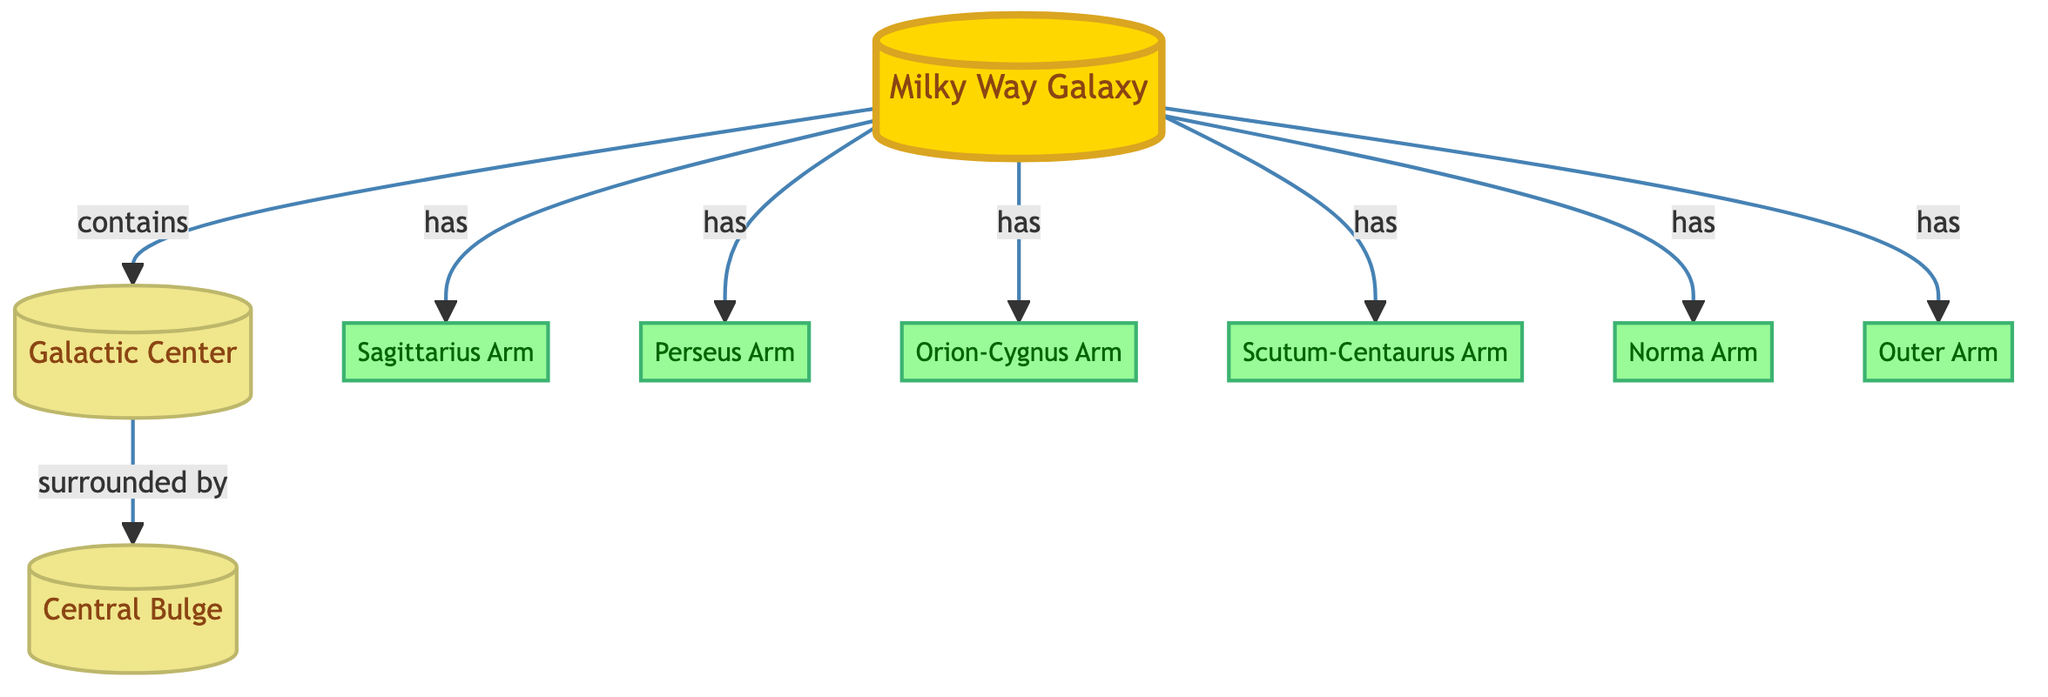What is the central feature of the Milky Way Galaxy? The central feature is the "Galactic Center," which is directly connected to the Milky Way Galaxy in the diagram.
Answer: Galactic Center How many spiral arms are shown in the diagram? The diagram indicates the presence of six spiral arms branching from the Milky Way Galaxy, each labeled as an arm, which are connected by the 'has' relationship.
Answer: 6 Which arm is directly linked to the Central Bulge? The "Central Bulge" is surrounded by the "Galactic Center," which connects to it in the diagram; however, the arms do not directly link to it. Since there is no arm connected directly to the Central Bulge, there is no answer for this question based on the tree structure shown.
Answer: None List the names of the spiral arms. The spiral arms listed in the diagram include Sagittarius Arm, Perseus Arm, Orion-Cygnus Arm, Scutum-Centaurus Arm, Norma Arm, and Outer Arm; each is directly associated with the Milky Way Galaxy node.
Answer: Sagittarius Arm, Perseus Arm, Orion-Cygnus Arm, Scutum-Centaurus Arm, Norma Arm, Outer Arm Which spiral arm is located closest to the Galactic Center? The "Orion-Cygnus Arm" is commonly recognized as the one nearest to the Galactic Center based on its position in the visual layout; it is a central feature among the arms listed in relation to the central nodes.
Answer: Orion-Cygnus Arm Is the Norma arm linked to the Milky Way galaxy? The diagram explicitly indicates that the "Norma Arm" is connected to the "Milky Way Galaxy" with the 'has' relationship, showing that it is a component within this structure.
Answer: Yes What does the Milky Way Galaxy contain according to the diagram? The Milky Way Galaxy contains various features, including Central Bulge, Galactic Center, and six identifiable spiral arms, as represented in their respective relationships.
Answer: Central Bulge, Galactic Center, 6 arms Which spiral arm has a name starting with 'S'? The diagram shows two arms beginning with 'S': "Sagittarius Arm" and "Scutum-Centaurus Arm," indicating they are both part of the structure.
Answer: Sagittarius Arm, Scutum-Centaurus Arm 